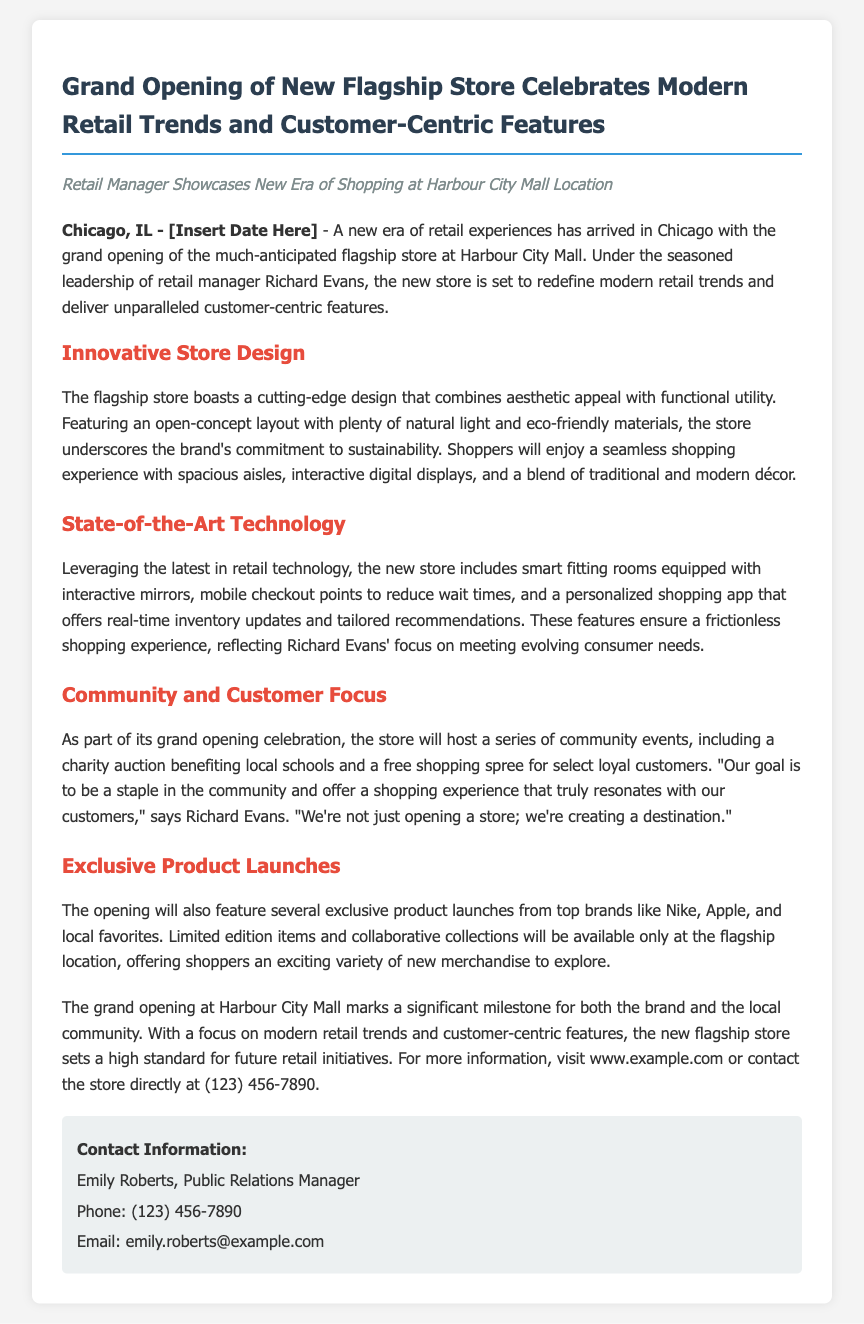What is the location of the new flagship store? The document states that the new flagship store is located at Harbour City Mall.
Answer: Harbour City Mall Who is the retail manager mentioned in the press release? The press release mentions Richard Evans as the retail manager overseeing the new store.
Answer: Richard Evans What technological feature does the store include to enhance the shopping experience? The store includes smart fitting rooms equipped with interactive mirrors as a technological feature to enhance shopping.
Answer: Smart fitting rooms What type of community event is mentioned in the press release? The press release mentions a charity auction benefiting local schools as part of the community events.
Answer: Charity auction What brands will feature exclusive product launches at the opening? The press release lists brands like Nike and Apple, among others, that will have exclusive product launches.
Answer: Nike, Apple What is the primary goal of the store as expressed by Richard Evans? Richard Evans expresses that the primary goal of the store is to create a destination that resonates with customers.
Answer: Create a destination On what date is the grand opening event scheduled? The document has a placeholder for the date of the grand opening, which needs to be filled in.
Answer: [Insert Date Here] What kind of store layout is featured in the flagship store? The press release describes the store layout as open-concept.
Answer: Open-concept 